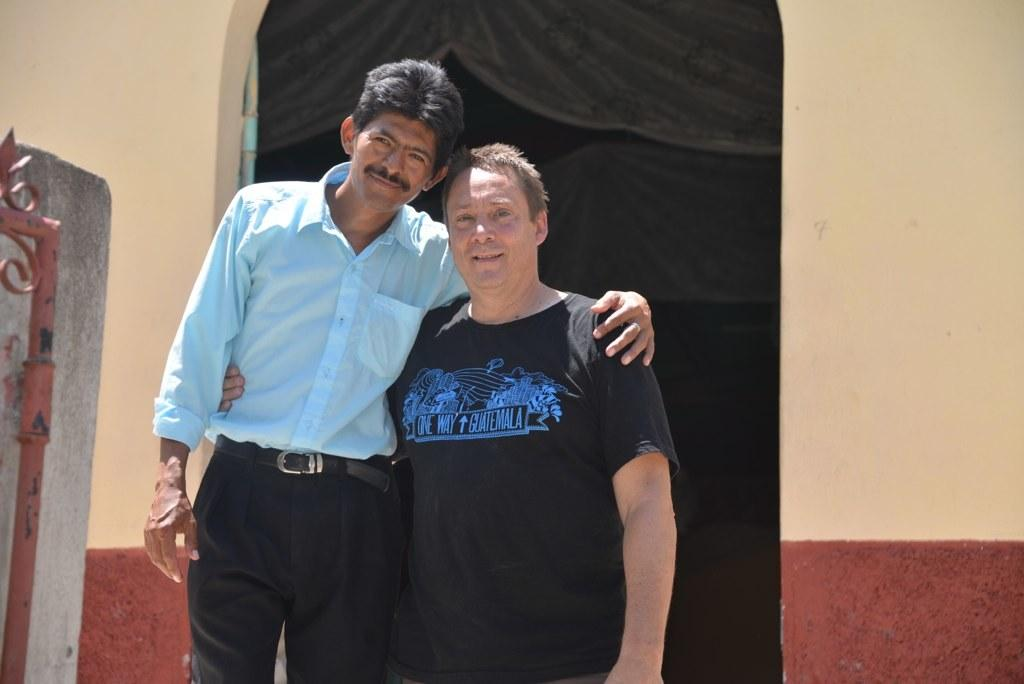How many people are in the foreground of the image? There are two men standing in the foreground of the image. What are the men doing in the image? The men are posing for a camera. What can be seen in the background of the image? There appears to be a gate and an arch leading to a wall in the background of the image. What type of brick is used to build the bath in the image? There is no bath present in the image, so it is not possible to determine the type of brick used. 